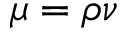Convert formula to latex. <formula><loc_0><loc_0><loc_500><loc_500>\mu = \rho \nu</formula> 